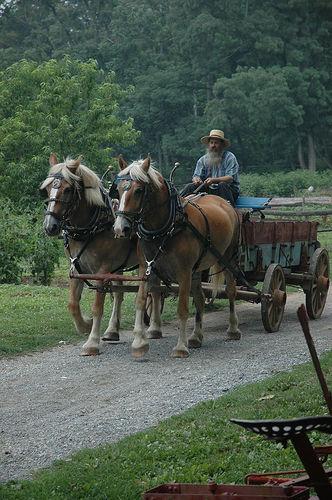What is the farmer pulling?
Keep it brief. Wagon. Is he transporting goods?
Answer briefly. No. What type of animal is in the picture?
Quick response, please. Horse. What color are the horses?
Concise answer only. Brown. Is it sunny out?
Give a very brief answer. No. Is this a modern time period?
Write a very short answer. No. 